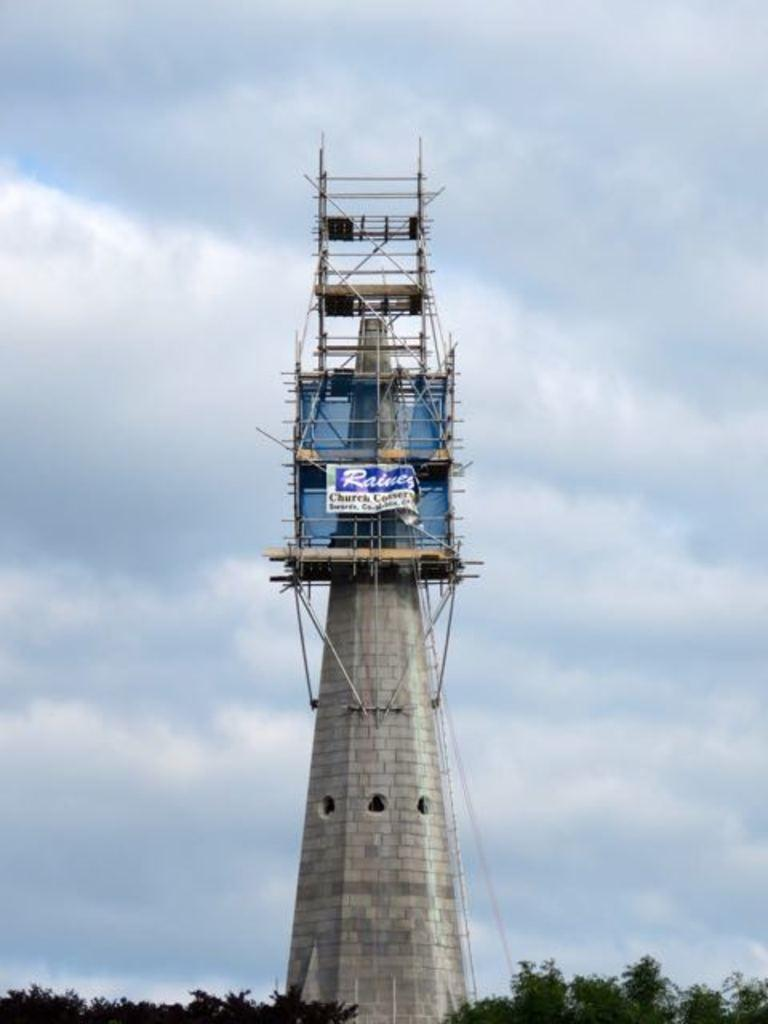What is the main structure in the image? There is a tower in the image. What can be seen below the tower? There are trees below the tower. What is visible in the background of the image? The sky is visible in the background of the image. Can you tell me how many goldfish are swimming in the tower? There are no goldfish present in the image; it features a tower and trees. What type of transport is available for people to reach the top of the tower in the image? The image does not show any specific means of transport to reach the top of the tower. 